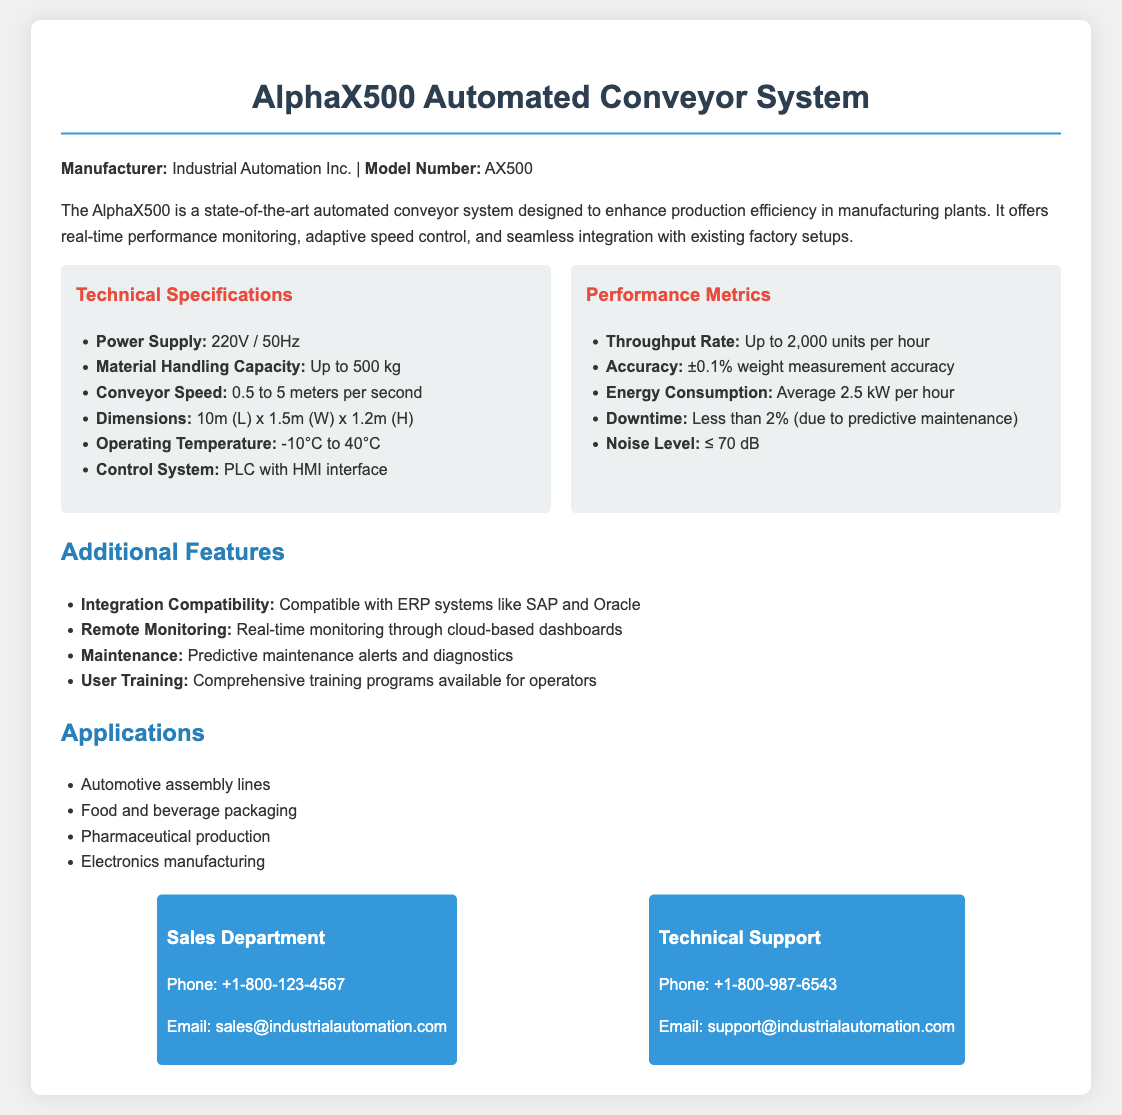What is the model number of the conveyor system? The model number is specifically mentioned in the introduction section of the document.
Answer: AX500 What is the maximum material handling capacity? This information is provided in the Technical Specifications section.
Answer: Up to 500 kg What is the average energy consumption? This metric is found in the Performance Metrics section, detailing energy usage.
Answer: Average 2.5 kW per hour What is the throughput rate of the system? The throughput rate is outlined in the Performance Metrics section.
Answer: Up to 2,000 units per hour What is the operating temperature range for the conveyor? The operating temperature is included in the Technical Specifications part of the document.
Answer: -10°C to 40°C How is the conveyor system controlled? The method of control for the conveyor is specified under Technical Specifications.
Answer: PLC with HMI interface What is the noise level of the system? The noise level is a critical performance metric listed in the Performance Metrics section.
Answer: ≤ 70 dB What type of applications is the conveyor system suitable for? The applications are detailed under the Applications section of the document.
Answer: Automotive assembly lines, Food and beverage packaging, Pharmaceutical production, Electronics manufacturing What kind of support is offered for users? This information is found in the Additional Features section related to user training.
Answer: Comprehensive training programs available for operators 